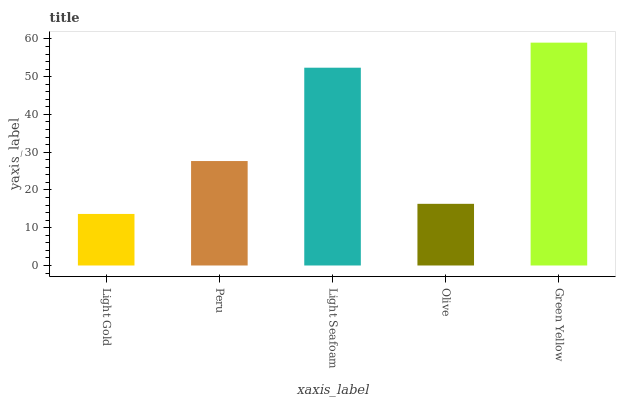Is Light Gold the minimum?
Answer yes or no. Yes. Is Green Yellow the maximum?
Answer yes or no. Yes. Is Peru the minimum?
Answer yes or no. No. Is Peru the maximum?
Answer yes or no. No. Is Peru greater than Light Gold?
Answer yes or no. Yes. Is Light Gold less than Peru?
Answer yes or no. Yes. Is Light Gold greater than Peru?
Answer yes or no. No. Is Peru less than Light Gold?
Answer yes or no. No. Is Peru the high median?
Answer yes or no. Yes. Is Peru the low median?
Answer yes or no. Yes. Is Green Yellow the high median?
Answer yes or no. No. Is Light Seafoam the low median?
Answer yes or no. No. 